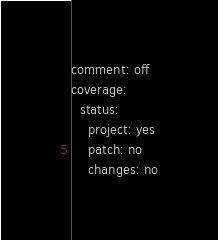<code> <loc_0><loc_0><loc_500><loc_500><_YAML_>comment: off
coverage:
  status:
    project: yes
    patch: no
    changes: no
</code> 